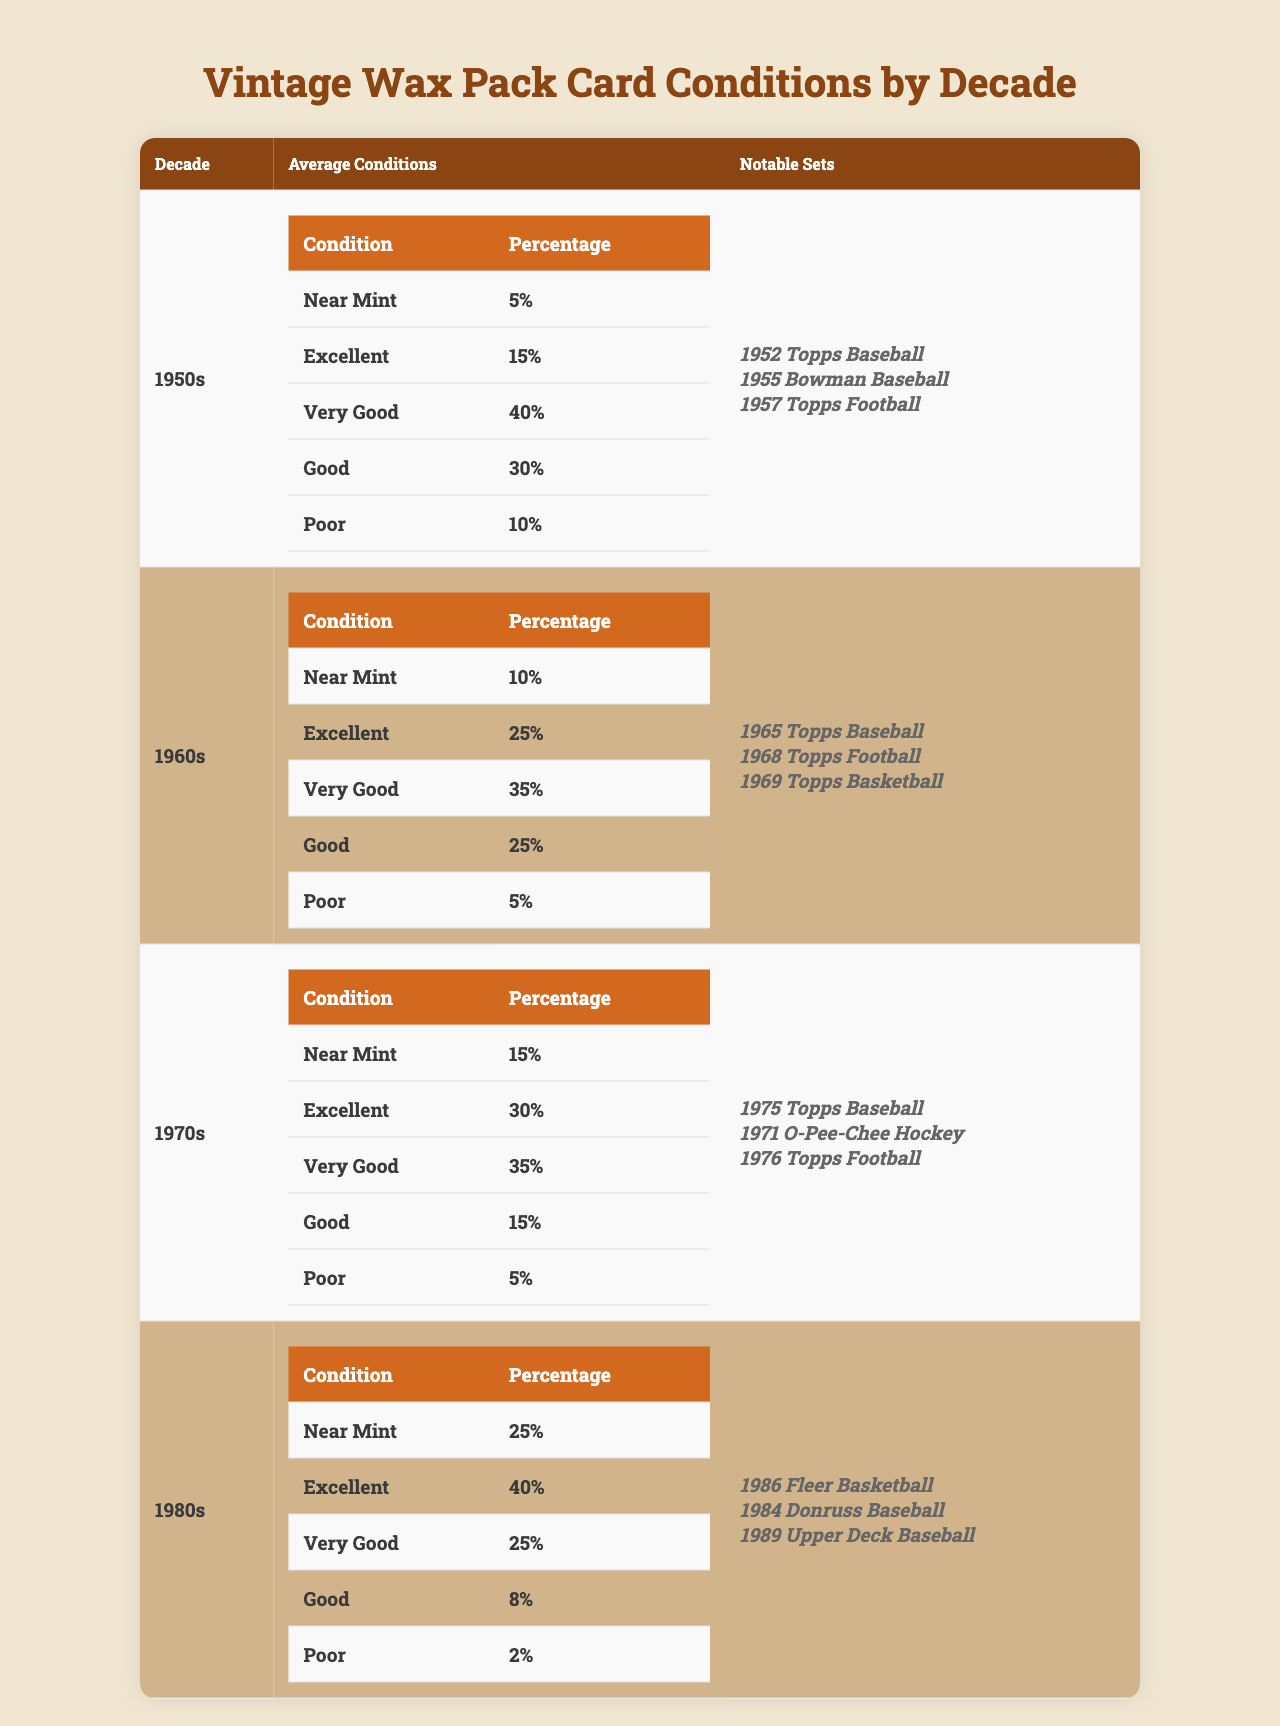What percentage of cards from the 1980s were in Good condition? The 1980s have 8% of cards listed under Good condition according to the table.
Answer: 8% Which decade had the highest percentage of cards in Near Mint condition? Looking at the table, the 1980s had the highest percentage of Near Mint cards at 25%.
Answer: 1980s What is the total percentage of cards in Excellent and Very Good condition for the 1960s? For the 1960s, Excellent is 25% and Very Good is 35%. Adding them together gives 25 + 35 = 60%.
Answer: 60% Did the percentage of cards classified as Poor decrease from the 1950s to the 1980s? In the 1950s, Poor was 10%, and in the 1980s, it dropped to 2%. Since it decreased, the statement is true.
Answer: Yes In which decade was the percentage of cards classified as Very Good the highest? The 1970s had 35% of cards rated as Very Good, which is the highest among all decades.
Answer: 1970s If we add the percentages of Near Mint and Excellent cards for both the 1970s and the 1980s, what is the result? The 1970s had 15% Near Mint and 30% Excellent (total 15 + 30 = 45%), while the 1980s had 25% Near Mint and 40% Excellent (total 25 + 40 = 65%). Adding these totals gives 45 + 65 = 110%.
Answer: 110% Are there any notable sets listed for the 1950s that were also produced in the 1970s? The notable sets for both decades are distinct; the sets listed for the 1950s do not appear in the 1970s, indicating there are no overlapping notable sets.
Answer: No Which decade had the lowest percentage of cards in Excellent condition? The 1950s had the lowest percentage of Excellent cards at only 15%, as evidenced by the comparison across decades.
Answer: 1950s Based on the table, what can we say about the trend in card conditions from the 1950s to the 1980s? Analyzing the data, there is a general increase in the percentages of Near Mint and Excellent conditions over the decades, while Poor conditions decreased significantly.
Answer: Improved conditions 